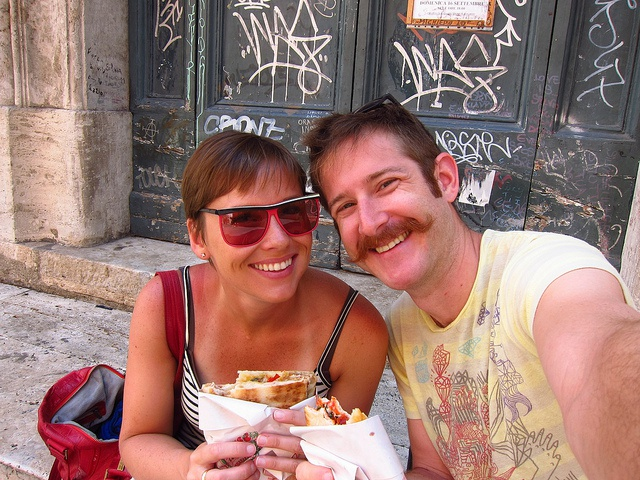Describe the objects in this image and their specific colors. I can see people in tan, lightpink, salmon, and white tones, people in darkgray, brown, maroon, and salmon tones, handbag in tan, brown, maroon, black, and gray tones, sandwich in tan, brown, and lightgray tones, and sandwich in tan, ivory, orange, and red tones in this image. 